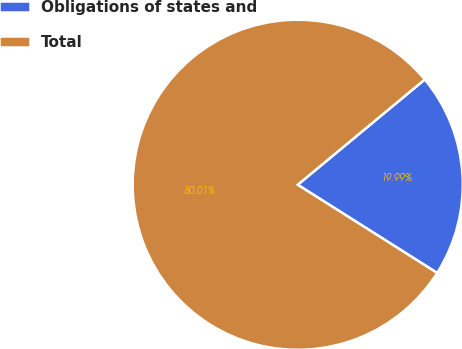<chart> <loc_0><loc_0><loc_500><loc_500><pie_chart><fcel>Obligations of states and<fcel>Total<nl><fcel>19.99%<fcel>80.01%<nl></chart> 